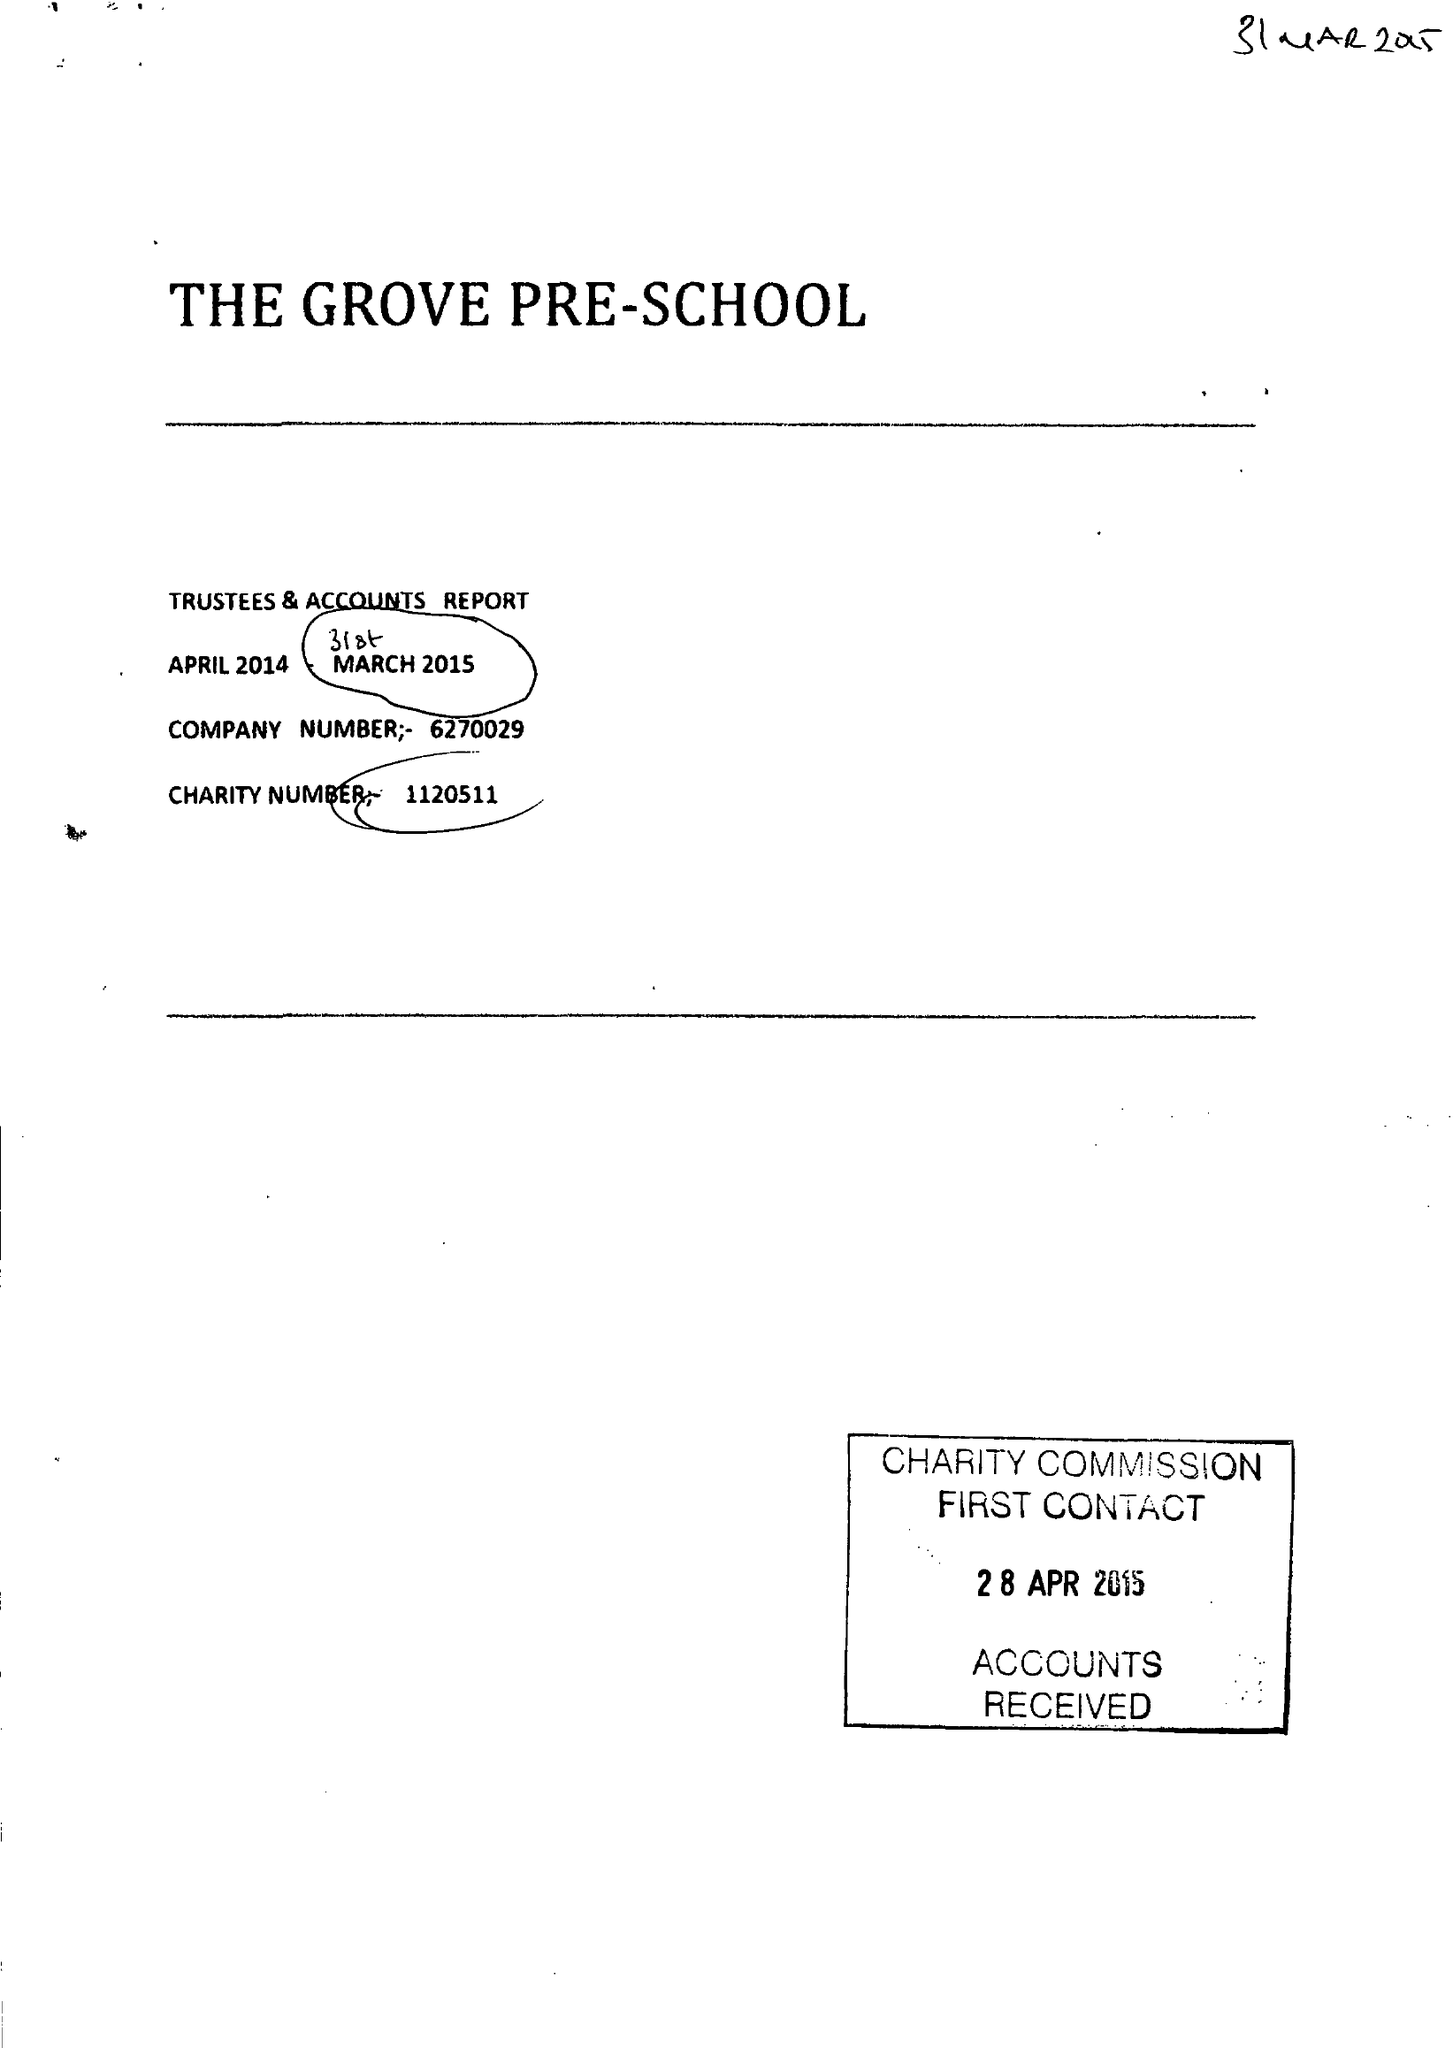What is the value for the address__post_town?
Answer the question using a single word or phrase. CHESTER LE STREET 